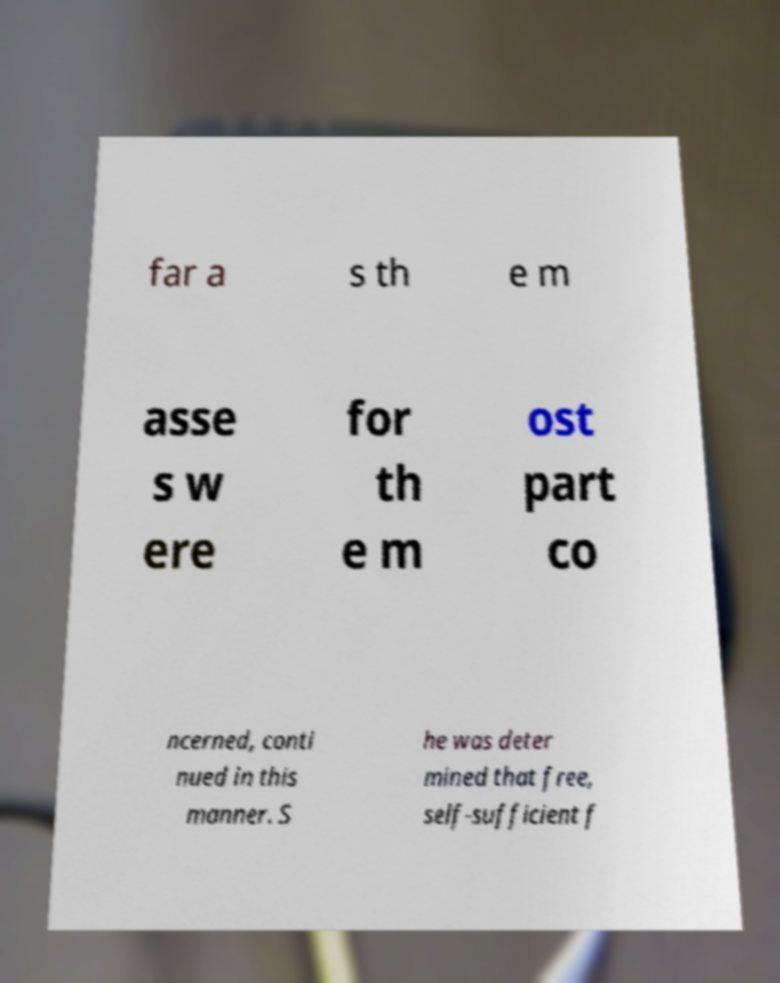What messages or text are displayed in this image? I need them in a readable, typed format. far a s th e m asse s w ere for th e m ost part co ncerned, conti nued in this manner. S he was deter mined that free, self-sufficient f 